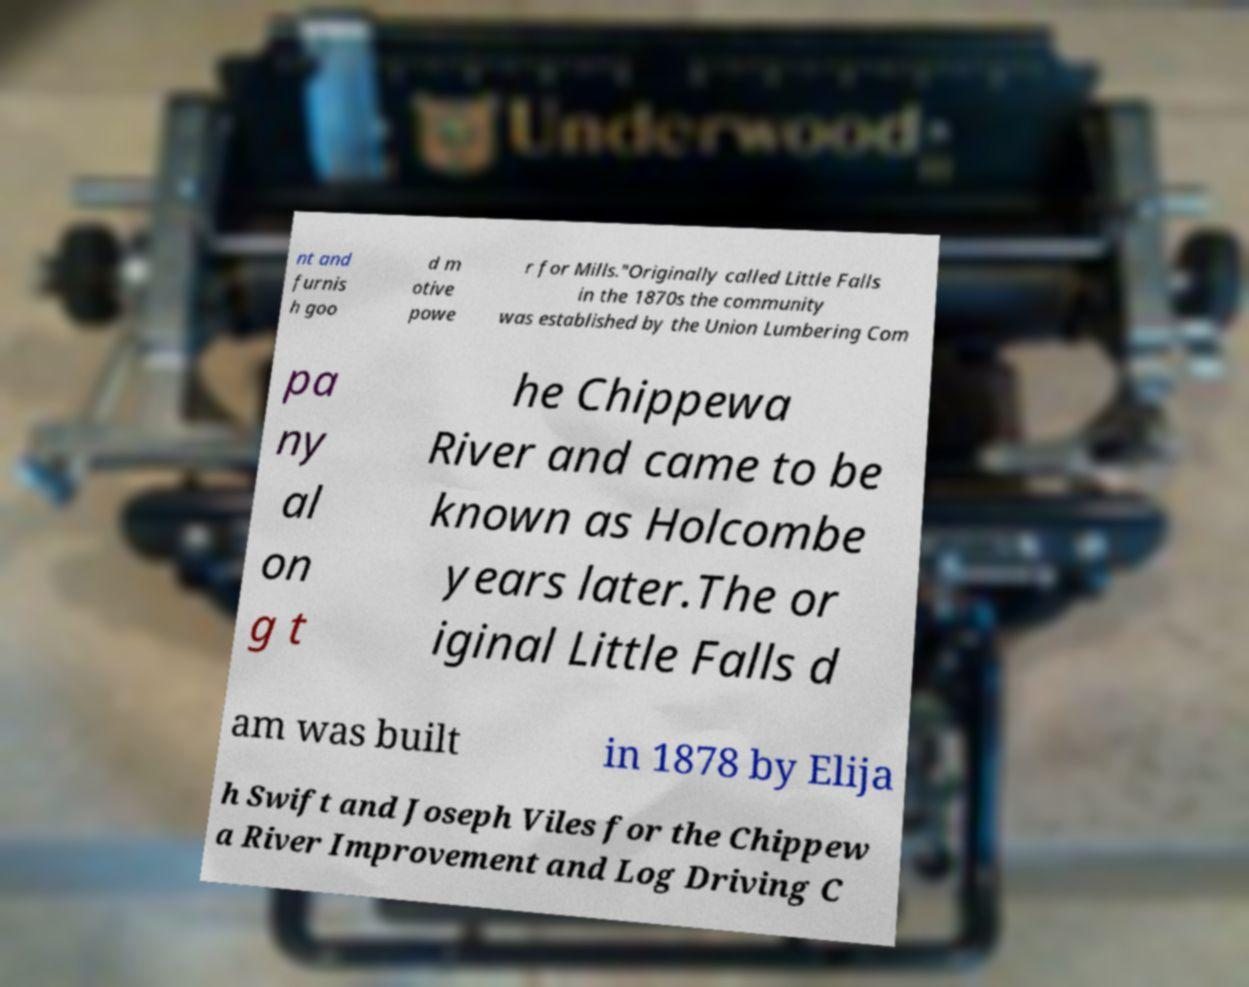For documentation purposes, I need the text within this image transcribed. Could you provide that? nt and furnis h goo d m otive powe r for Mills."Originally called Little Falls in the 1870s the community was established by the Union Lumbering Com pa ny al on g t he Chippewa River and came to be known as Holcombe years later.The or iginal Little Falls d am was built in 1878 by Elija h Swift and Joseph Viles for the Chippew a River Improvement and Log Driving C 